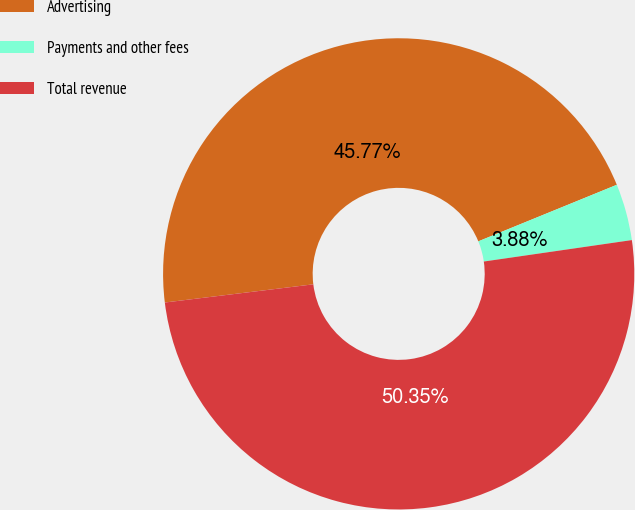Convert chart to OTSL. <chart><loc_0><loc_0><loc_500><loc_500><pie_chart><fcel>Advertising<fcel>Payments and other fees<fcel>Total revenue<nl><fcel>45.77%<fcel>3.88%<fcel>50.35%<nl></chart> 